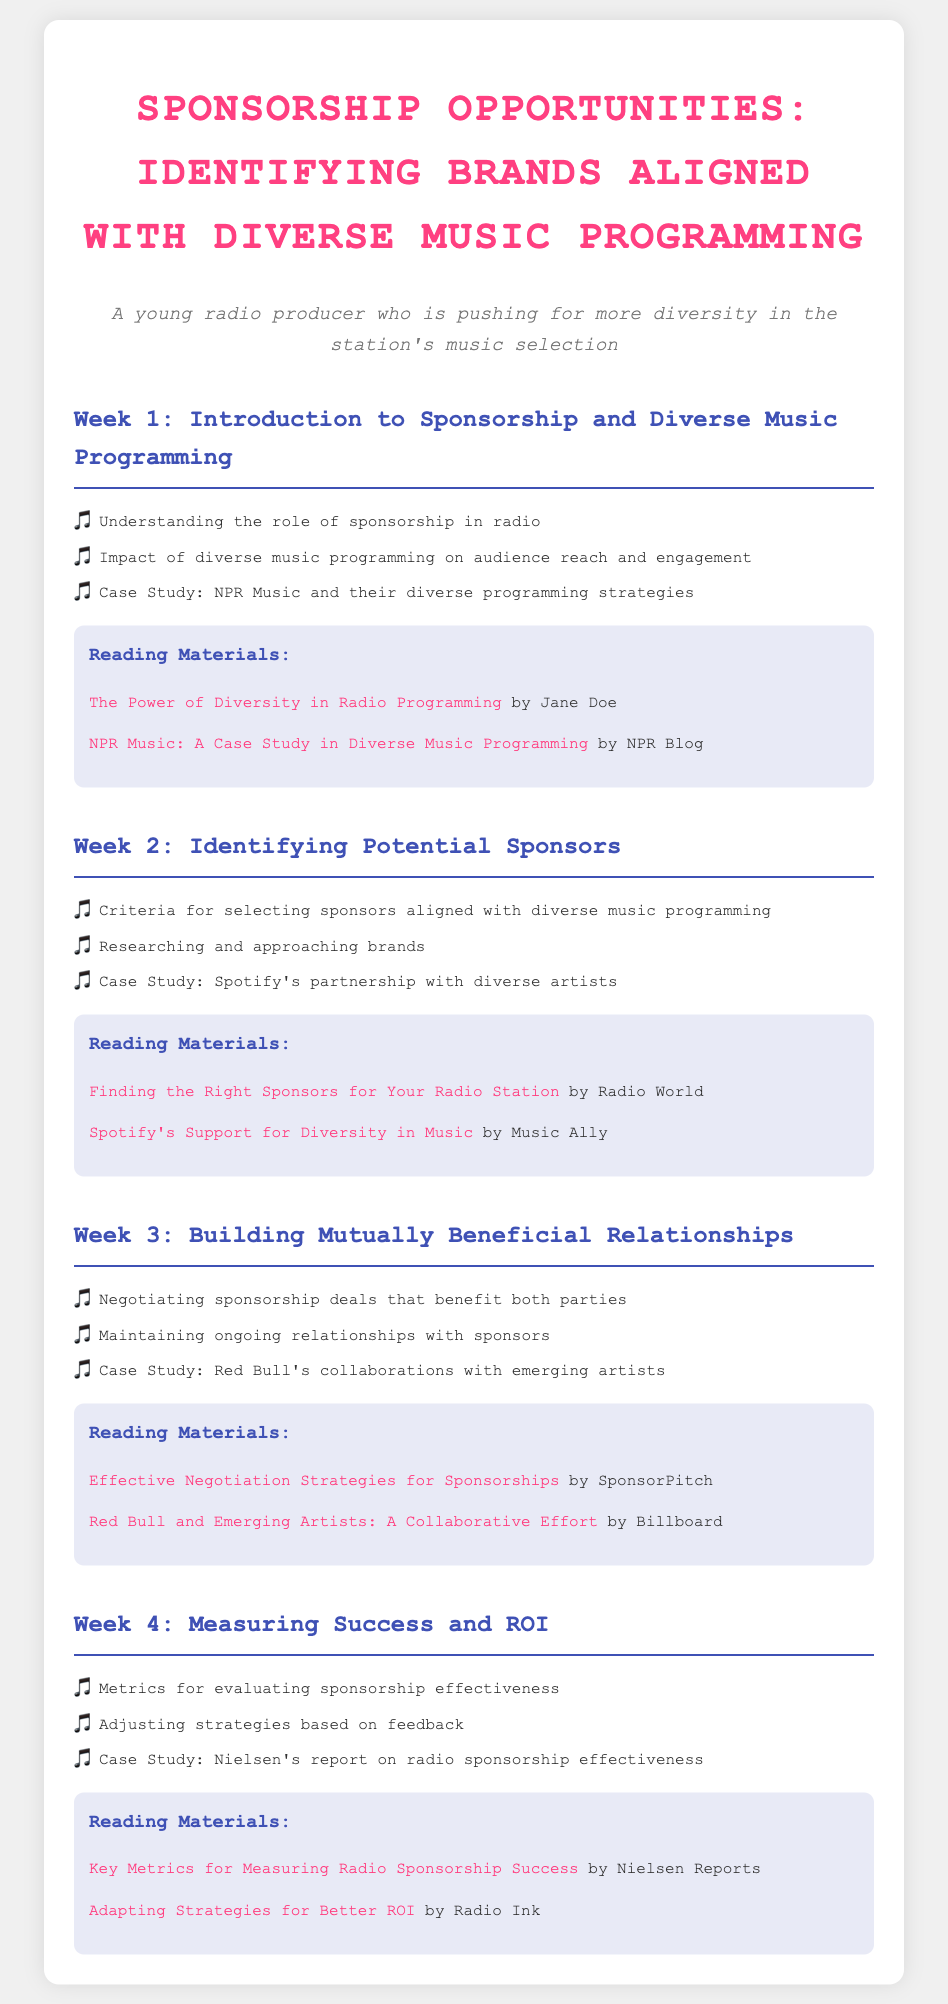what is the title of the document? The title of the document is stated at the top, which is about sponsorship opportunities related to music programming.
Answer: Sponsorship Opportunities: Identifying Brands Aligned with Diverse Music Programming who is the target audience of the document? The document introduces a persona, which indicates the target audience, focusing on a young radio producer.
Answer: A young radio producer how many weeks are covered in the syllabus? The syllabus outlines four distinct weeks, each with specific topics related to sponsorship.
Answer: 4 what is one of the criteria for selecting sponsors? The document states that selecting sponsors should be based on alignment with diverse music programming.
Answer: Alignment with diverse music programming which organization is used as a case study for diverse programming in week 1? The case study mentioned in week 1 showcases a reputable music-focused organization involved in diverse programming efforts.
Answer: NPR Music what topic is covered in week 3? The syllabus lists a specific aspect of building relationships in sponsorships for week 3.
Answer: Building Mutually Beneficial Relationships which brand's efforts are highlighted as a case study for week 2? The document features a well-known streaming service's partnership activities in week 2.
Answer: Spotify what is the focus of week 4? The final week's focus is on evaluating the effectiveness of the sponsorships based on certain metrics.
Answer: Measuring Success and ROI 